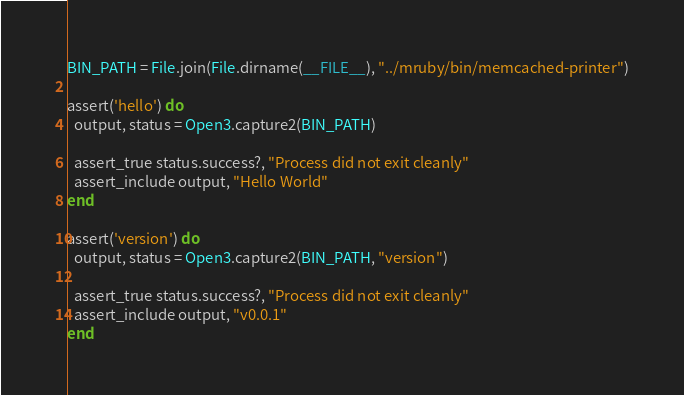<code> <loc_0><loc_0><loc_500><loc_500><_Ruby_>
BIN_PATH = File.join(File.dirname(__FILE__), "../mruby/bin/memcached-printer")

assert('hello') do
  output, status = Open3.capture2(BIN_PATH)

  assert_true status.success?, "Process did not exit cleanly"
  assert_include output, "Hello World"
end

assert('version') do
  output, status = Open3.capture2(BIN_PATH, "version")

  assert_true status.success?, "Process did not exit cleanly"
  assert_include output, "v0.0.1"
end
</code> 